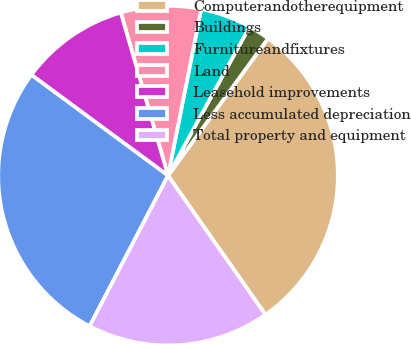<chart> <loc_0><loc_0><loc_500><loc_500><pie_chart><fcel>Computerandotherequipment<fcel>Buildings<fcel>Furnitureandfixtures<fcel>Land<fcel>Leasehold improvements<fcel>Less accumulated depreciation<fcel>Total property and equipment<nl><fcel>30.25%<fcel>2.06%<fcel>4.84%<fcel>7.62%<fcel>10.4%<fcel>27.47%<fcel>17.37%<nl></chart> 